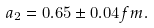<formula> <loc_0><loc_0><loc_500><loc_500>a _ { 2 } = 0 . 6 5 \pm 0 . 0 4 f m .</formula> 